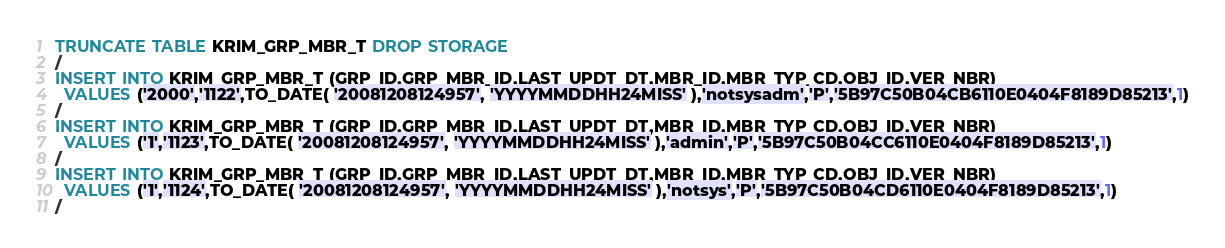Convert code to text. <code><loc_0><loc_0><loc_500><loc_500><_SQL_>TRUNCATE TABLE KRIM_GRP_MBR_T DROP STORAGE
/
INSERT INTO KRIM_GRP_MBR_T (GRP_ID,GRP_MBR_ID,LAST_UPDT_DT,MBR_ID,MBR_TYP_CD,OBJ_ID,VER_NBR)
  VALUES ('2000','1122',TO_DATE( '20081208124957', 'YYYYMMDDHH24MISS' ),'notsysadm','P','5B97C50B04CB6110E0404F8189D85213',1)
/
INSERT INTO KRIM_GRP_MBR_T (GRP_ID,GRP_MBR_ID,LAST_UPDT_DT,MBR_ID,MBR_TYP_CD,OBJ_ID,VER_NBR)
  VALUES ('1','1123',TO_DATE( '20081208124957', 'YYYYMMDDHH24MISS' ),'admin','P','5B97C50B04CC6110E0404F8189D85213',1)
/
INSERT INTO KRIM_GRP_MBR_T (GRP_ID,GRP_MBR_ID,LAST_UPDT_DT,MBR_ID,MBR_TYP_CD,OBJ_ID,VER_NBR)
  VALUES ('1','1124',TO_DATE( '20081208124957', 'YYYYMMDDHH24MISS' ),'notsys','P','5B97C50B04CD6110E0404F8189D85213',1)
/
</code> 